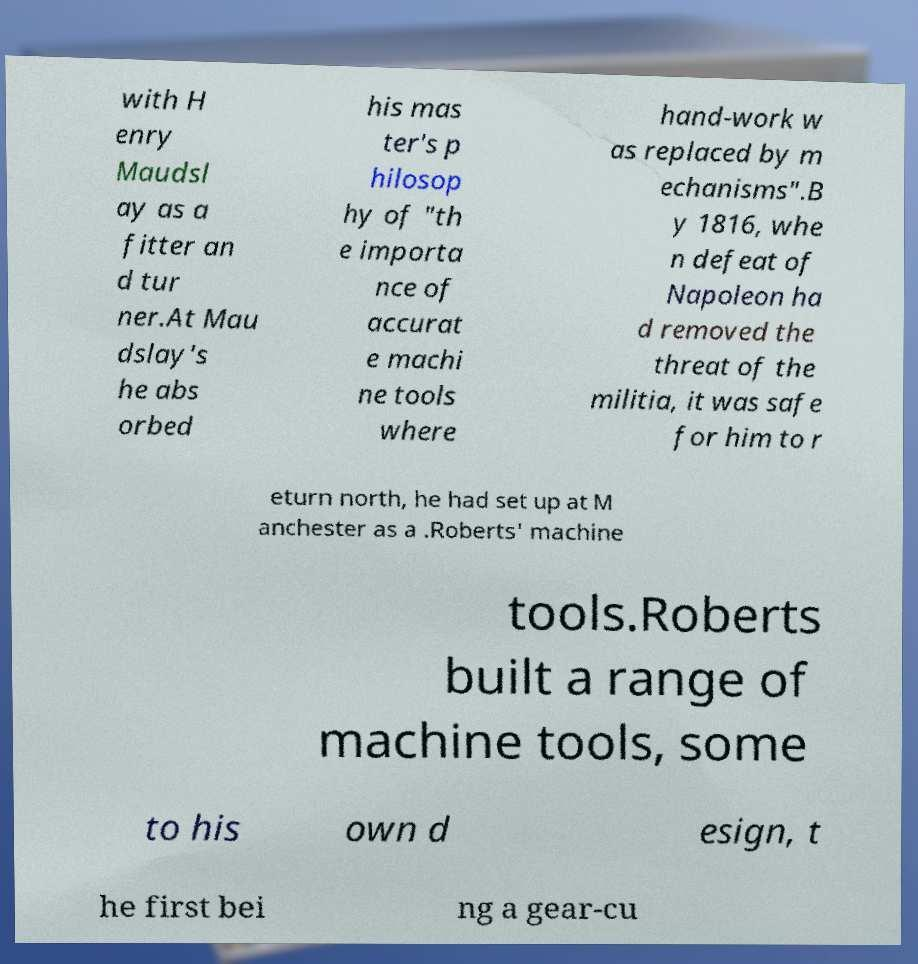Please read and relay the text visible in this image. What does it say? with H enry Maudsl ay as a fitter an d tur ner.At Mau dslay's he abs orbed his mas ter's p hilosop hy of "th e importa nce of accurat e machi ne tools where hand-work w as replaced by m echanisms".B y 1816, whe n defeat of Napoleon ha d removed the threat of the militia, it was safe for him to r eturn north, he had set up at M anchester as a .Roberts' machine tools.Roberts built a range of machine tools, some to his own d esign, t he first bei ng a gear-cu 